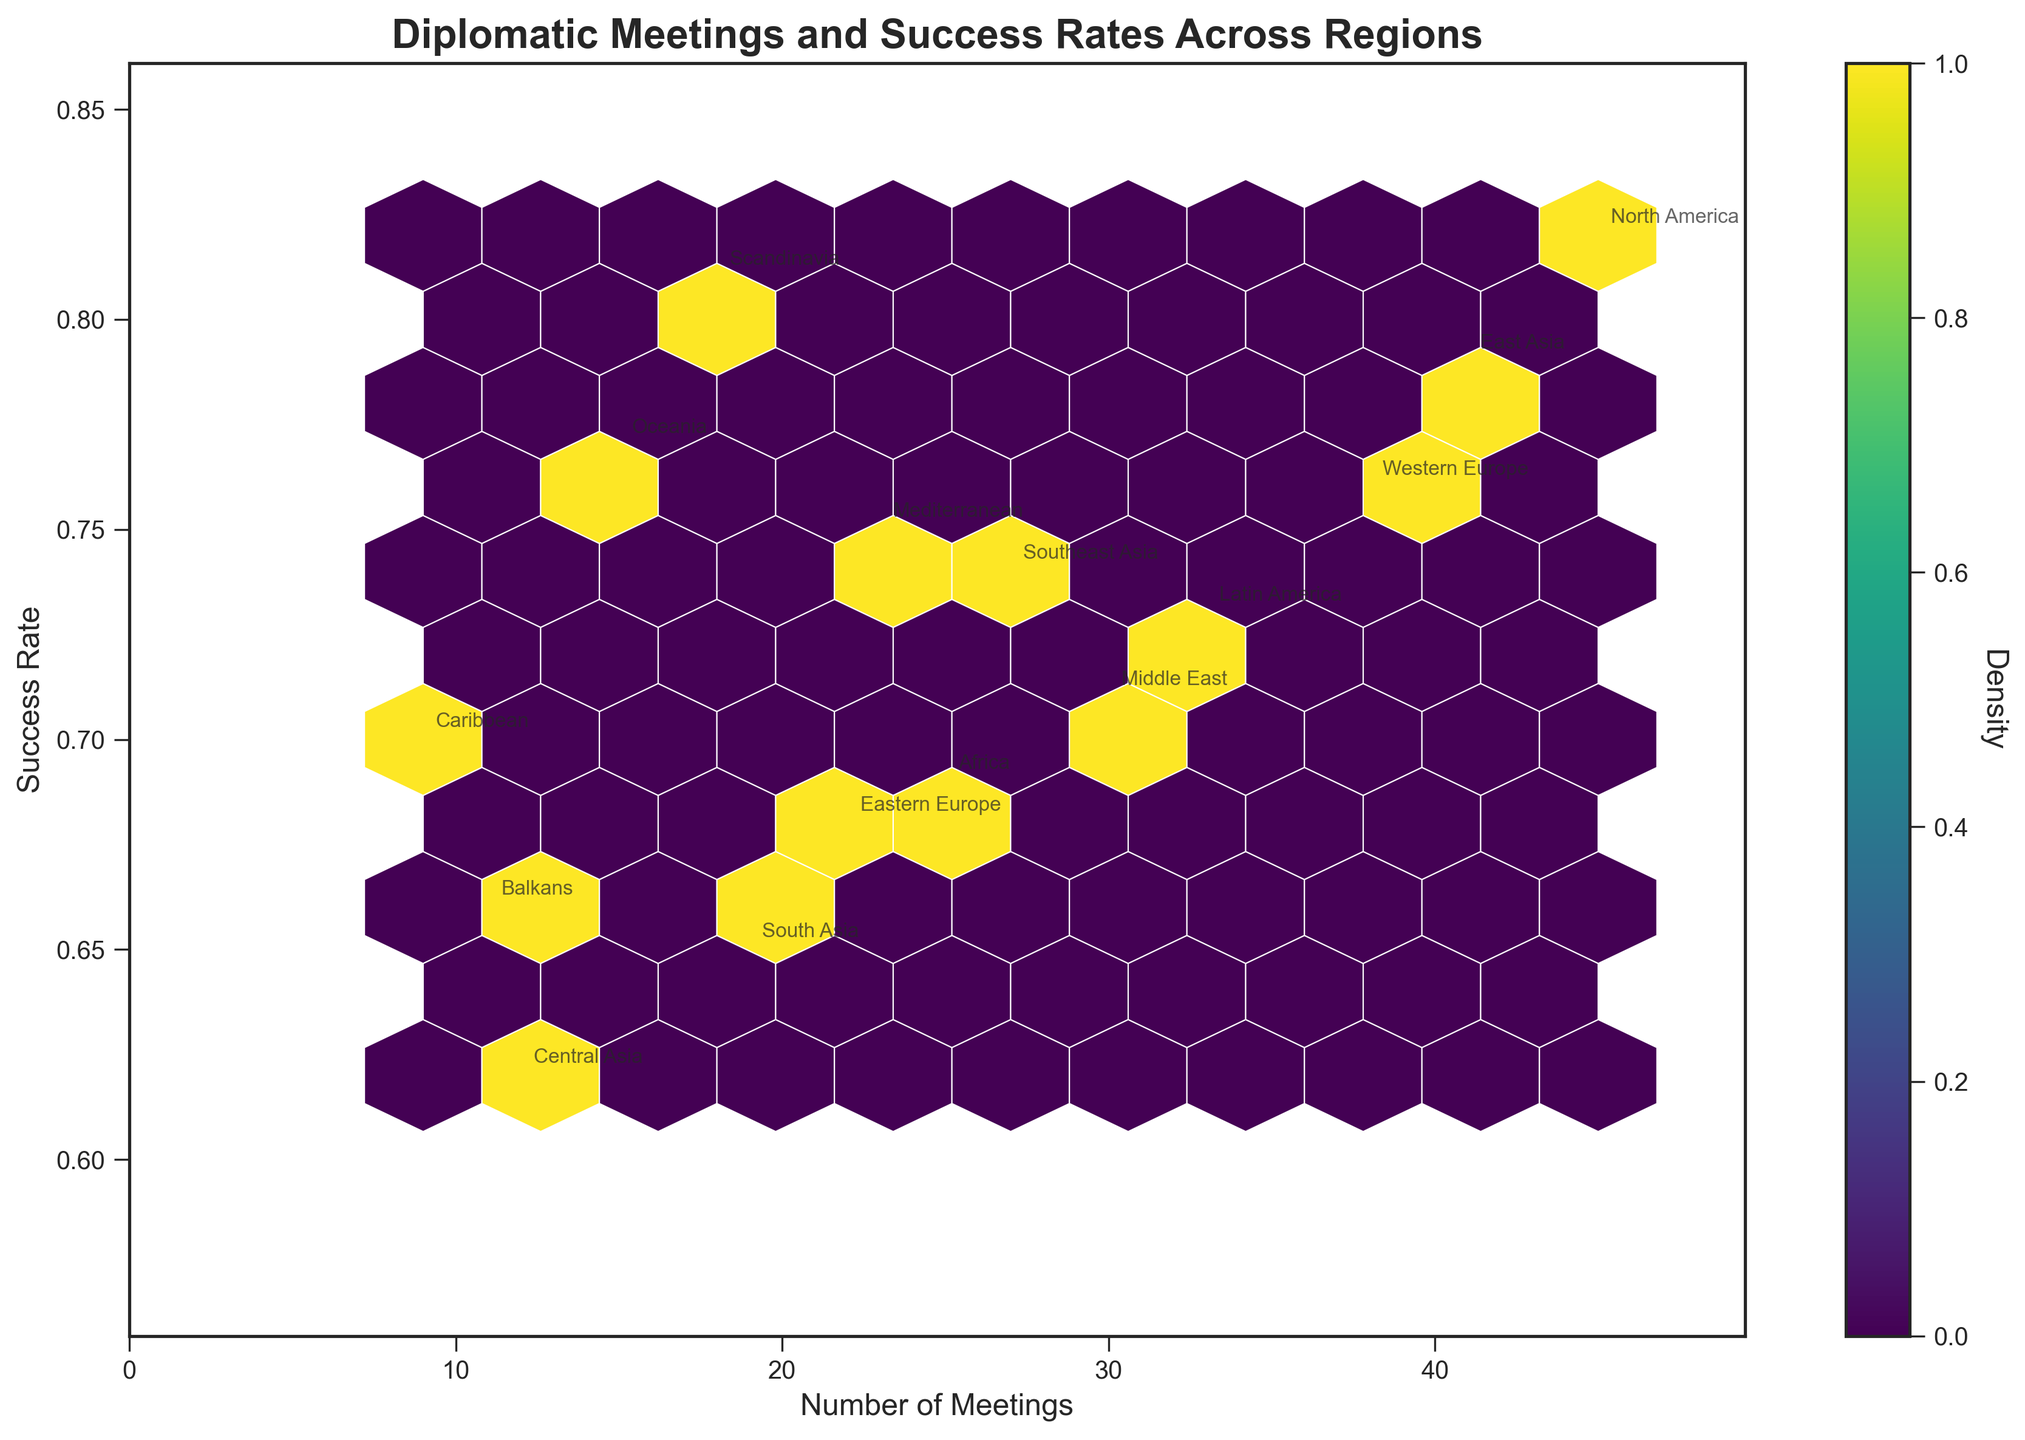What's the title of the chart? The title of the chart is written at the top of the figure and indicates the main topic it represents. You can directly read the title from the figure.
Answer: Diplomatic Meetings and Success Rates Across Regions What are the labels of the X and Y axes? These labels are typically placed along the horizontal and vertical axes to denote what each axis represents. The X-axis label indicates the number of meetings, and the Y-axis label indicates the success rate of those meetings.
Answer: Number of Meetings (X-axis), Success Rate (Y-axis) Which region has the highest success rate? To determine the region with the highest success rate, look for the data point with the highest Y-axis value, then check the region's label annotated at this point.
Answer: North America and Scandinavia How does the number of meetings in East Asia compare to that in Western Europe? To compare the number of meetings between these two regions, find their respective points on the X-axis and note the X-axis values.
Answer: East Asia has more meetings than Western Europe What is the range of the success rates displayed? To find the range, identify the minimum and maximum values along the Y-axis where the data points are located.
Answer: 0.62 to 0.82 How many regions fall within the 0.7 to 0.75 success rate range? Identify the data points that fall within the specified Y-axis interval (0.7 to 0.75) and count the corresponding regions.
Answer: Five regions Which regions have more than 30 meetings and a success rate above 0.75? Find the data points where the X-axis value is greater than 30 and the Y-axis value is greater than 0.75, then check the labels for these points.
Answer: North America and East Asia What is the density color scale used in the hexbin plot? The density color scale is indicated by the color gradient on the plot and the color bar, which goes from low to high density.
Answer: Viridis What is the relationship between the number of meetings and success rates generally seen in the chart? Observing the overall trend of the scatter points helps to determine if there is a positive, negative, or no correlation between the meetings and success rate values.
Answer: No clear trend 